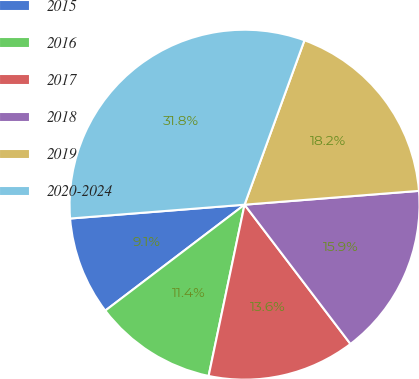Convert chart to OTSL. <chart><loc_0><loc_0><loc_500><loc_500><pie_chart><fcel>2015<fcel>2016<fcel>2017<fcel>2018<fcel>2019<fcel>2020-2024<nl><fcel>9.09%<fcel>11.36%<fcel>13.64%<fcel>15.91%<fcel>18.18%<fcel>31.82%<nl></chart> 